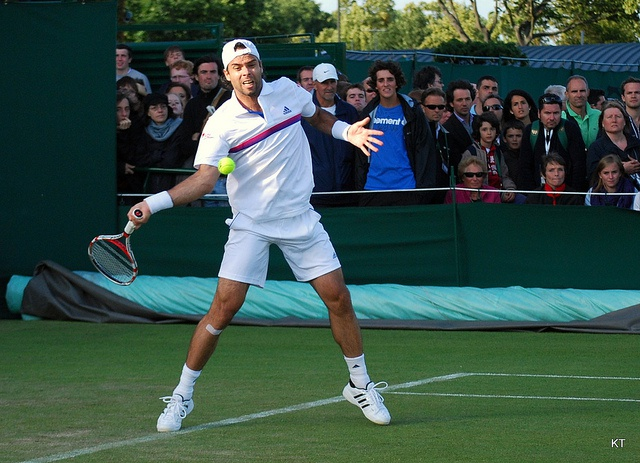Describe the objects in this image and their specific colors. I can see people in black, lightgray, darkgray, and lightblue tones, people in black, gray, maroon, and brown tones, people in black, blue, darkblue, and navy tones, people in black, blue, gray, and darkblue tones, and people in black, maroon, gray, and brown tones in this image. 